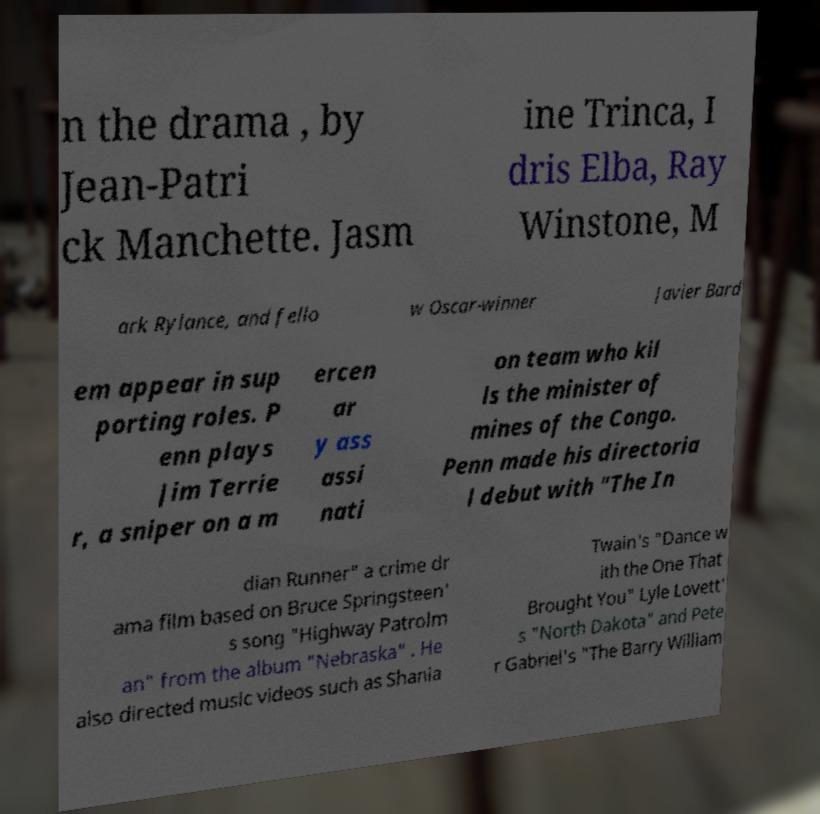Can you read and provide the text displayed in the image?This photo seems to have some interesting text. Can you extract and type it out for me? n the drama , by Jean-Patri ck Manchette. Jasm ine Trinca, I dris Elba, Ray Winstone, M ark Rylance, and fello w Oscar-winner Javier Bard em appear in sup porting roles. P enn plays Jim Terrie r, a sniper on a m ercen ar y ass assi nati on team who kil ls the minister of mines of the Congo. Penn made his directoria l debut with "The In dian Runner" a crime dr ama film based on Bruce Springsteen' s song "Highway Patrolm an" from the album "Nebraska" . He also directed music videos such as Shania Twain's "Dance w ith the One That Brought You" Lyle Lovett' s "North Dakota" and Pete r Gabriel's "The Barry William 